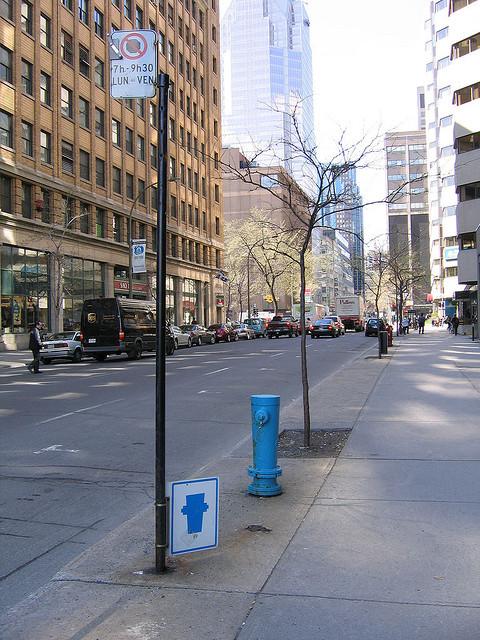What color is water hydrant?
Keep it brief. Blue. What is on the ground in the bottom left?
Write a very short answer. Pole. What color is the hydrant?
Write a very short answer. Blue. Are we facing the front of the signs?
Concise answer only. Yes. How many sunspots are there?
Be succinct. 25. How long is the pole?
Keep it brief. 10 ft. 